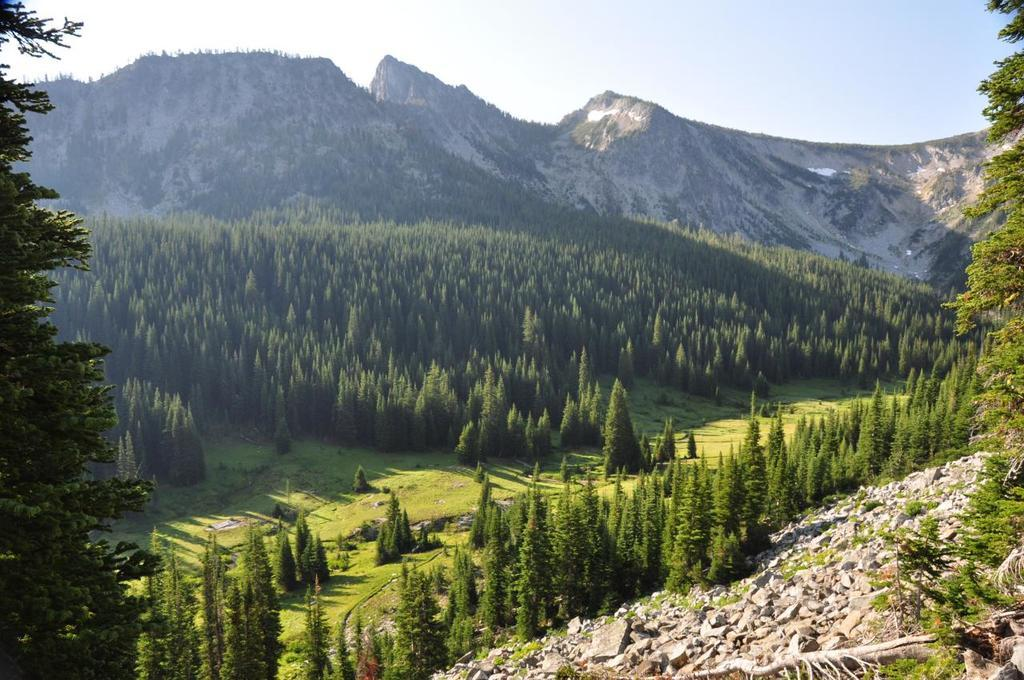Where was the picture taken? The picture was clicked outside the city. What can be seen in the foreground of the image? There are trees and stones in the foreground of the image. What is visible in the background of the image? There is a sky visible in the background of the image, along with hills and trees. What type of spoon is hanging from the tree in the image? There is no spoon present in the image; it only features trees, stones, sky, and hills. 